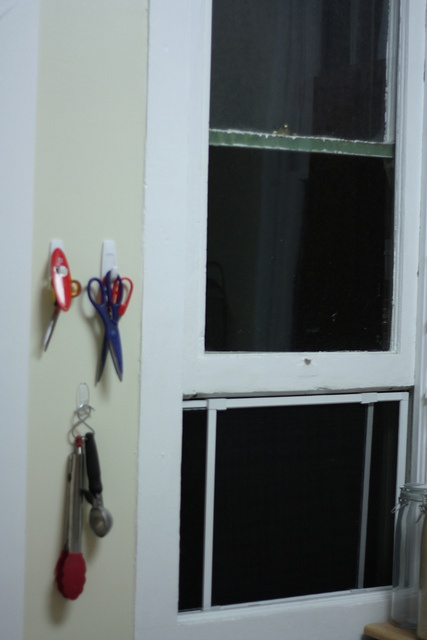Describe the objects in this image and their specific colors. I can see spoon in darkgray, black, maroon, and gray tones, scissors in darkgray, navy, gray, and black tones, spoon in darkgray, black, and gray tones, scissors in darkgray, black, brown, and gray tones, and scissors in darkgray, gray, maroon, and black tones in this image. 